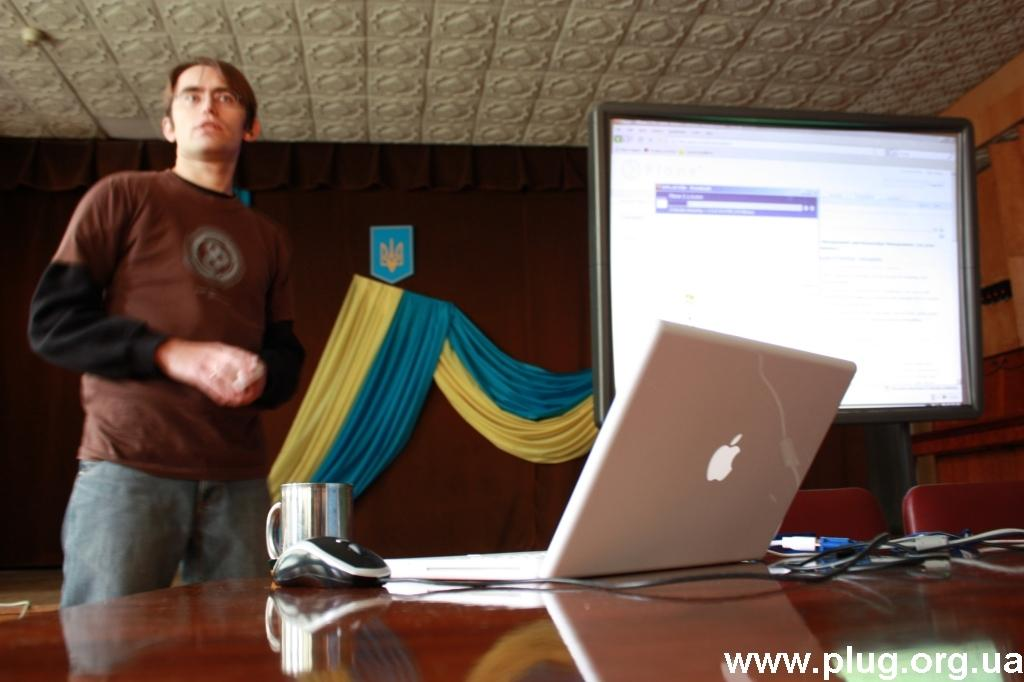What is in front of the wall in the image? There is a screen in front of the wall in the image. What is the person standing beside in the image? The person is standing beside a table in the image. What electronic device is on the table? There is a laptop on the table in the image. What other items are on the table? Cables, a mouse, and a cup are present on the table in the image. What is the person's opinion about the brain in the image? There is no mention of a brain or the person's opinion in the image. How does the person stop the screen from displaying content in the image? There is no indication of the person interacting with the screen or stopping its display in the image. 